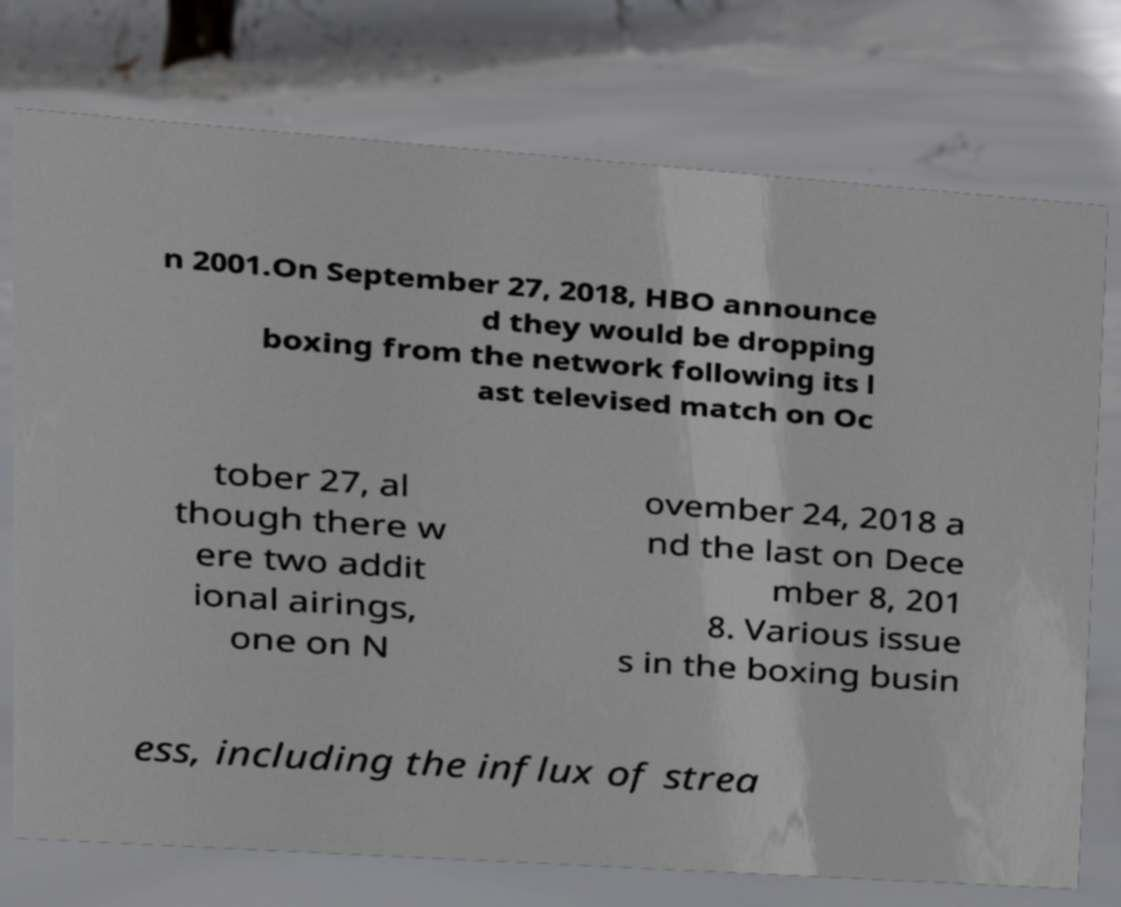Can you read and provide the text displayed in the image?This photo seems to have some interesting text. Can you extract and type it out for me? n 2001.On September 27, 2018, HBO announce d they would be dropping boxing from the network following its l ast televised match on Oc tober 27, al though there w ere two addit ional airings, one on N ovember 24, 2018 a nd the last on Dece mber 8, 201 8. Various issue s in the boxing busin ess, including the influx of strea 